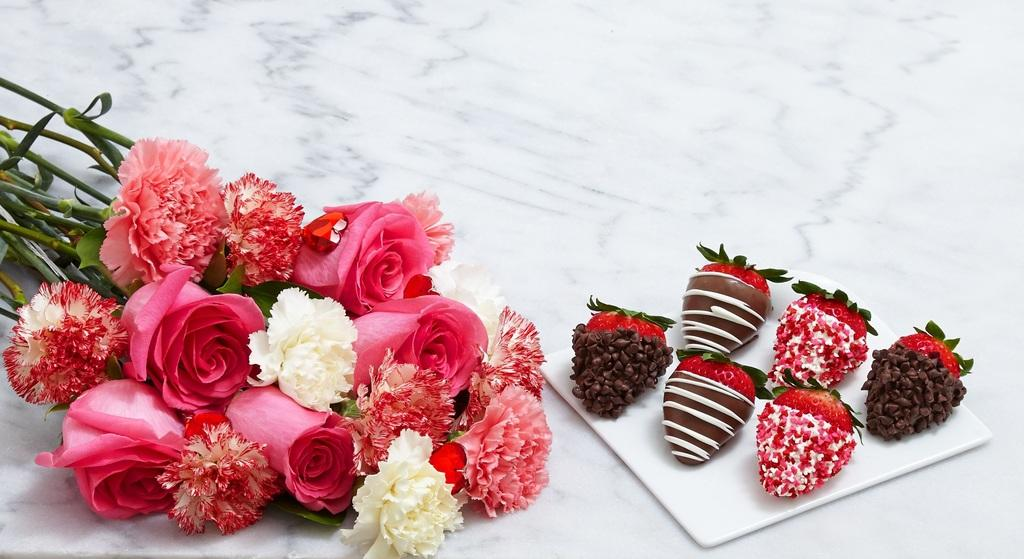What type of flowers are in the left corner of the image? There are roses in the left corner of the image. What type of fruit is in the right corner of the image? There are strawberries in the right corner of the image. What is placed on the strawberries? There is an object placed on the strawberries. What type of question is being asked in the image? There is no question present in the image; it features roses and strawberries with an object placed on the strawberries. What type of prose can be seen written on the roses? There is no prose written on the roses in the image. 